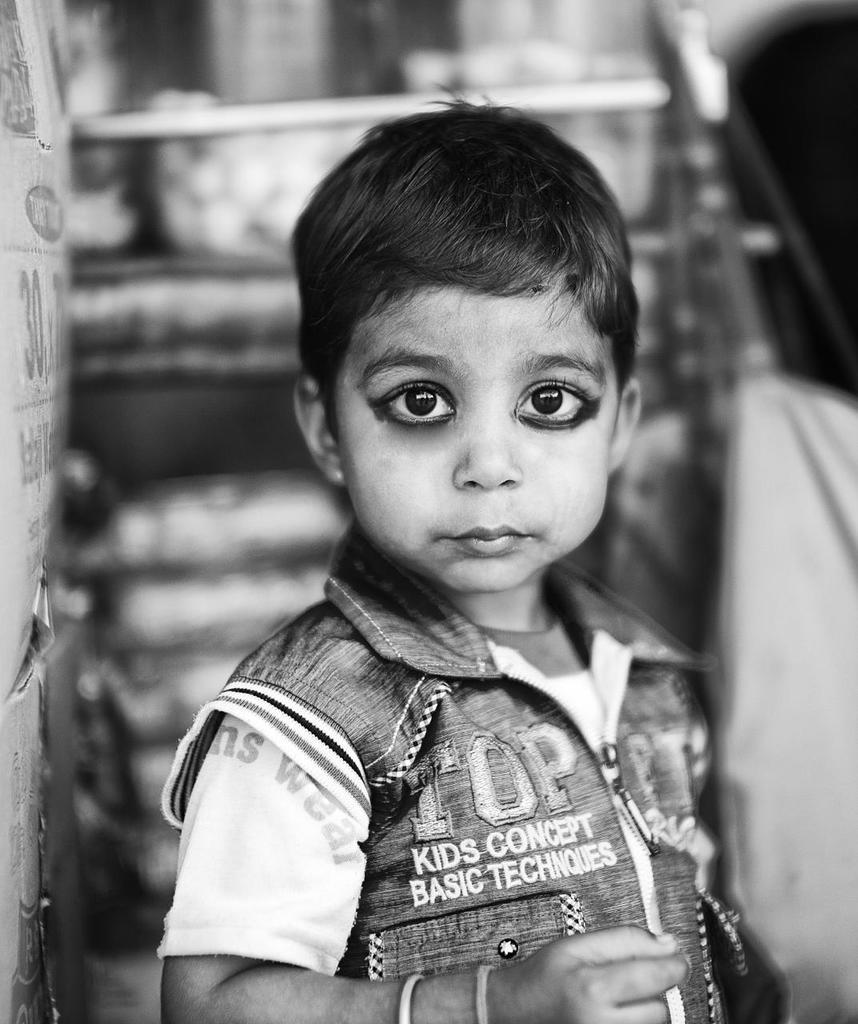Who is the main subject in the picture? There is a boy in the picture. What can be observed about the background of the image? The background of the picture is blurred. How would you describe the color scheme of the image? The picture is black and white in color. What type of milk is the boy holding in the picture? There is no milk present in the image; the boy is not holding anything. 